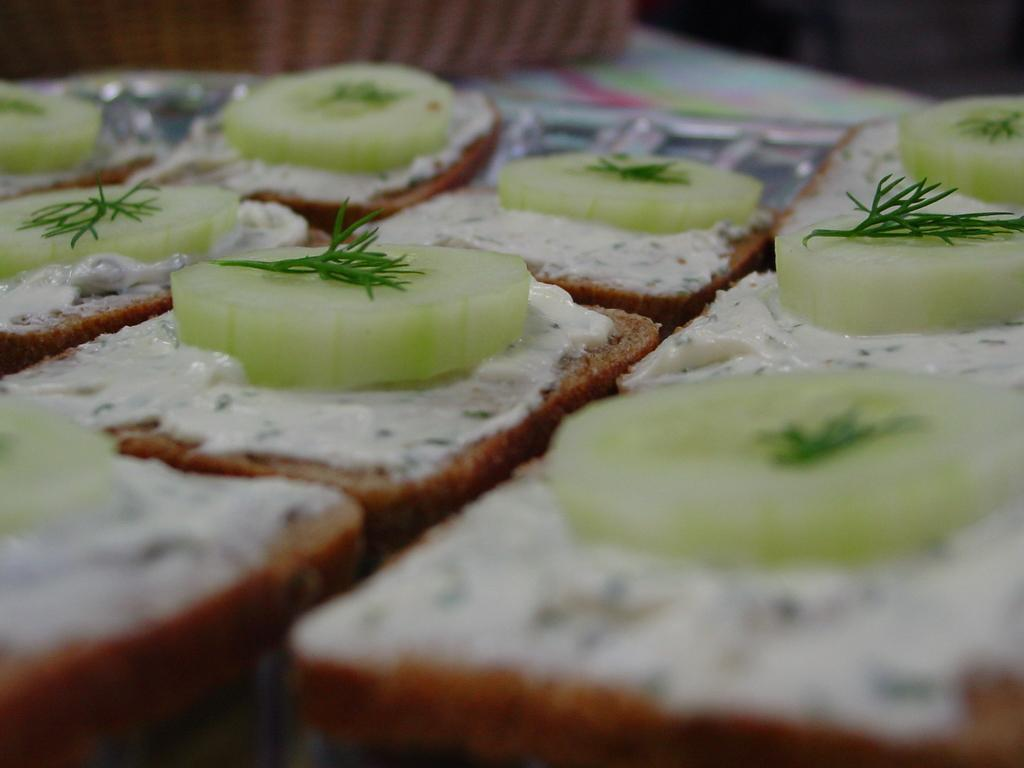What type of food can be seen in the image? There is bread in the image. Are there any other food items visible besides the bread? Yes, there are other food items in the image. What grade of glass is used to make the glassware in the image? There is no glassware present in the image, so it is not possible to determine the grade of glass used. 